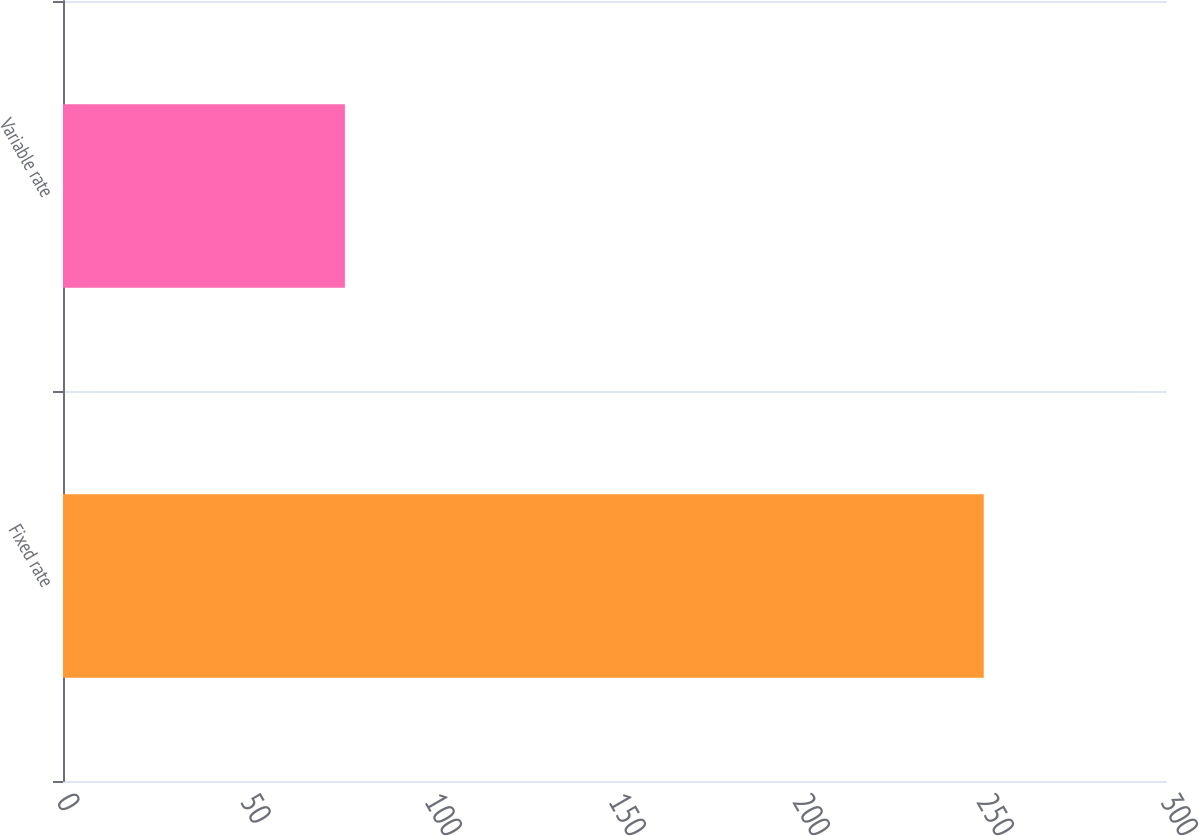<chart> <loc_0><loc_0><loc_500><loc_500><bar_chart><fcel>Fixed rate<fcel>Variable rate<nl><fcel>250.2<fcel>76.6<nl></chart> 